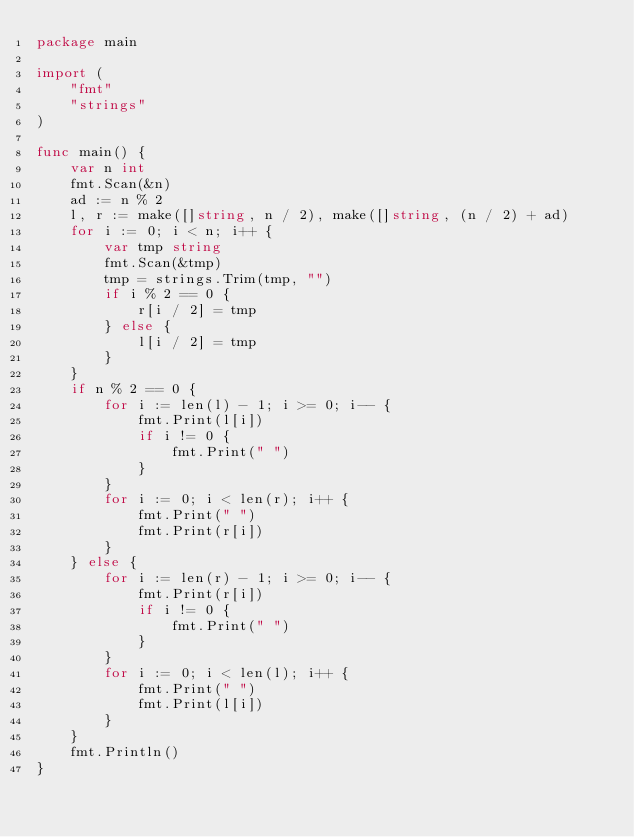Convert code to text. <code><loc_0><loc_0><loc_500><loc_500><_Go_>package main

import (
	"fmt"
	"strings"
)

func main() {
	var n int
	fmt.Scan(&n)
	ad := n % 2
	l, r := make([]string, n / 2), make([]string, (n / 2) + ad)
	for i := 0; i < n; i++ {
		var tmp string
		fmt.Scan(&tmp)
		tmp = strings.Trim(tmp, "")
		if i % 2 == 0 {
			r[i / 2] = tmp
		} else {
			l[i / 2] = tmp
		}
	}
	if n % 2 == 0 {
		for i := len(l) - 1; i >= 0; i-- {
			fmt.Print(l[i])
			if i != 0 {
				fmt.Print(" ")
			}
		}
		for i := 0; i < len(r); i++ {
			fmt.Print(" ")
			fmt.Print(r[i])
		}
	} else {
		for i := len(r) - 1; i >= 0; i-- {
			fmt.Print(r[i])
			if i != 0 {
				fmt.Print(" ")
			}
		}
		for i := 0; i < len(l); i++ {
			fmt.Print(" ")
			fmt.Print(l[i])
		}
	}
	fmt.Println()
}</code> 